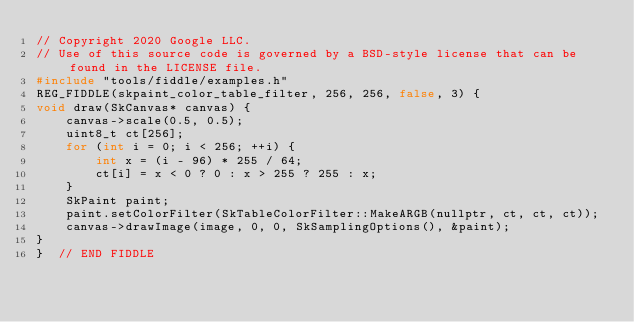<code> <loc_0><loc_0><loc_500><loc_500><_C++_>// Copyright 2020 Google LLC.
// Use of this source code is governed by a BSD-style license that can be found in the LICENSE file.
#include "tools/fiddle/examples.h"
REG_FIDDLE(skpaint_color_table_filter, 256, 256, false, 3) {
void draw(SkCanvas* canvas) {
    canvas->scale(0.5, 0.5);
    uint8_t ct[256];
    for (int i = 0; i < 256; ++i) {
        int x = (i - 96) * 255 / 64;
        ct[i] = x < 0 ? 0 : x > 255 ? 255 : x;
    }
    SkPaint paint;
    paint.setColorFilter(SkTableColorFilter::MakeARGB(nullptr, ct, ct, ct));
    canvas->drawImage(image, 0, 0, SkSamplingOptions(), &paint);
}
}  // END FIDDLE
</code> 